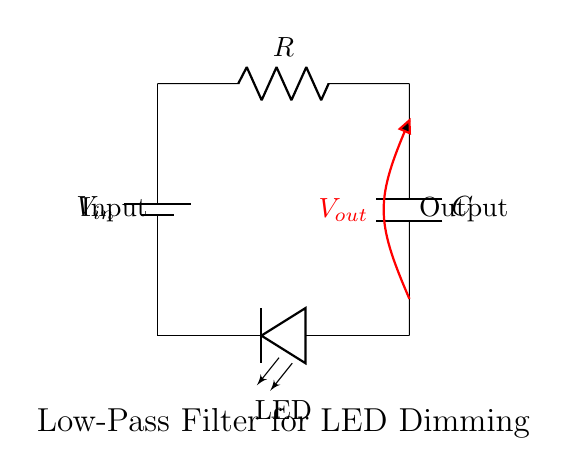What is the input voltage of this circuit? The input voltage is represented by \(V_{in}\) on the battery component, which provides the power supply to the circuit.
Answer: \(V_{in}\) What component is used for filtering in this circuit? The filtering component in this circuit is the capacitor, denoted as \(C\), which allows low-frequency signals to pass while attenuating high-frequency signals.
Answer: Capacitor How many major components are present in the circuit? The circuit contains four major components: a battery, a resistor, a capacitor, and an LED.
Answer: Four What is the output voltage labeled as in the circuit? The output voltage is labeled as \(V_{out}\), indicating the voltage across the LED. It is taken from the junction of the capacitor and the LED.
Answer: \(V_{out}\) What type of filter is implemented in this circuit? This circuit implements a low-pass filter, which allows lower frequency signals to pass through while blocking higher frequencies, making it suitable for dimming LED lights.
Answer: Low-pass filter How does the resistor affect the circuit operation? The resistor, labeled \(R\), affects the charging and discharging rate of the capacitor, which in turn influences how quickly the LED can dim or brighten as it modifies the current flow during the filtering process.
Answer: Current flow What is the function of the LED in this circuit? The LED serves as the load that receives the filtered voltage from the circuit, converting electrical energy into light while demonstrating the dimming effect of the low-pass filter.
Answer: Load 